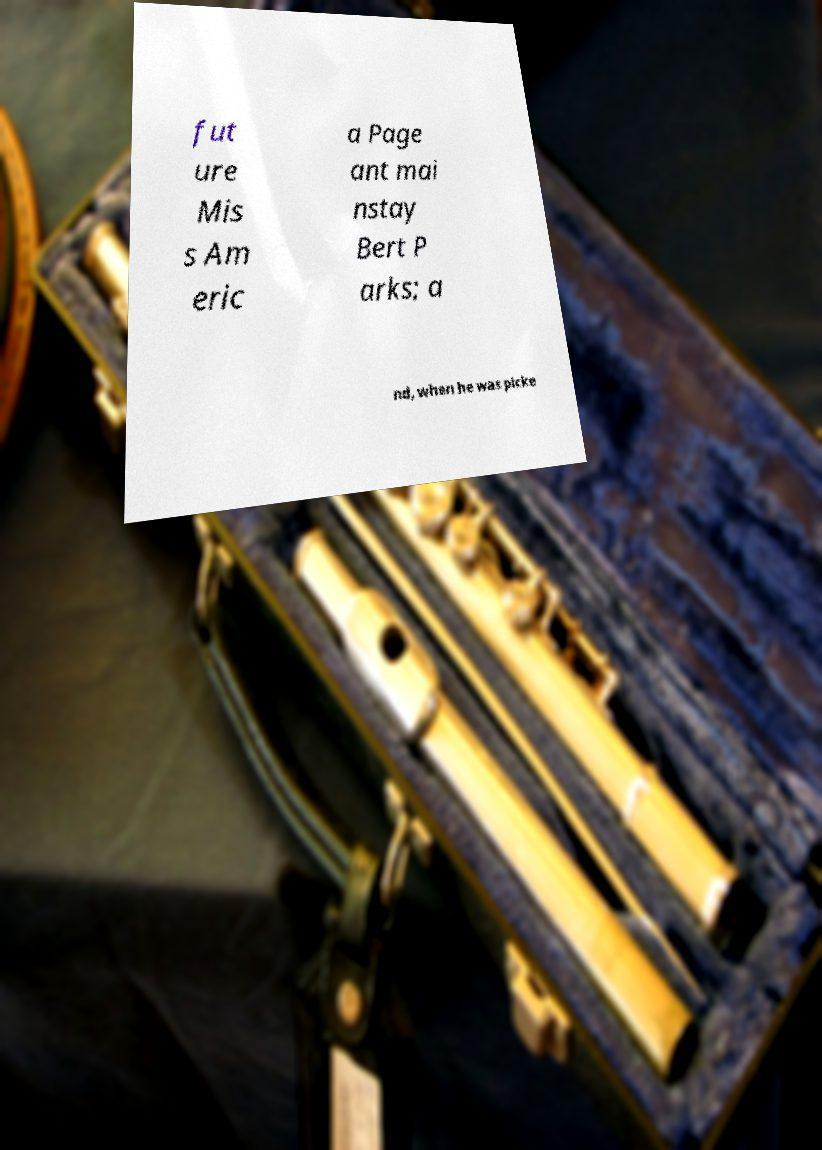Could you extract and type out the text from this image? fut ure Mis s Am eric a Page ant mai nstay Bert P arks; a nd, when he was picke 